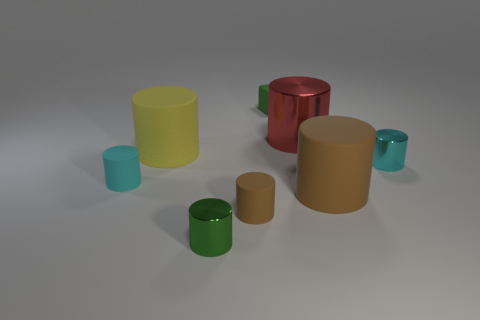Subtract all large brown cylinders. How many cylinders are left? 6 Subtract all yellow cylinders. How many cylinders are left? 6 Subtract all red cylinders. Subtract all cyan balls. How many cylinders are left? 6 Subtract all cyan cubes. How many brown cylinders are left? 2 Subtract all red shiny objects. Subtract all green metallic things. How many objects are left? 6 Add 3 big red metallic things. How many big red metallic things are left? 4 Add 3 tiny green metallic cylinders. How many tiny green metallic cylinders exist? 4 Add 2 large objects. How many objects exist? 10 Subtract 0 blue cylinders. How many objects are left? 8 Subtract all blocks. How many objects are left? 7 